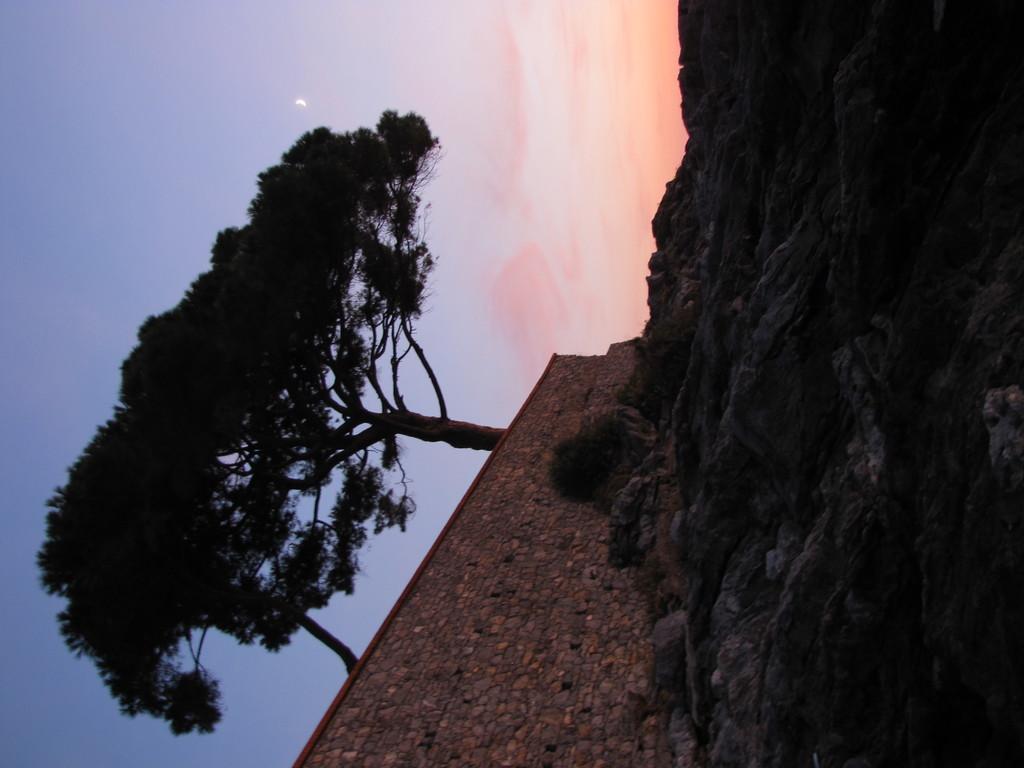Can you describe this image briefly? In the image I can see a place where we have some rocks and also I can see a wall and some trees. 